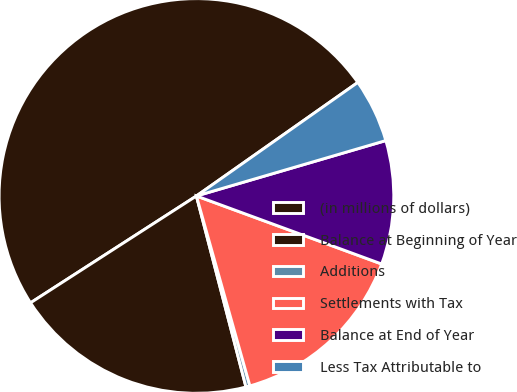<chart> <loc_0><loc_0><loc_500><loc_500><pie_chart><fcel>(in millions of dollars)<fcel>Balance at Beginning of Year<fcel>Additions<fcel>Settlements with Tax<fcel>Balance at End of Year<fcel>Less Tax Attributable to<nl><fcel>49.35%<fcel>19.93%<fcel>0.33%<fcel>15.03%<fcel>10.13%<fcel>5.23%<nl></chart> 